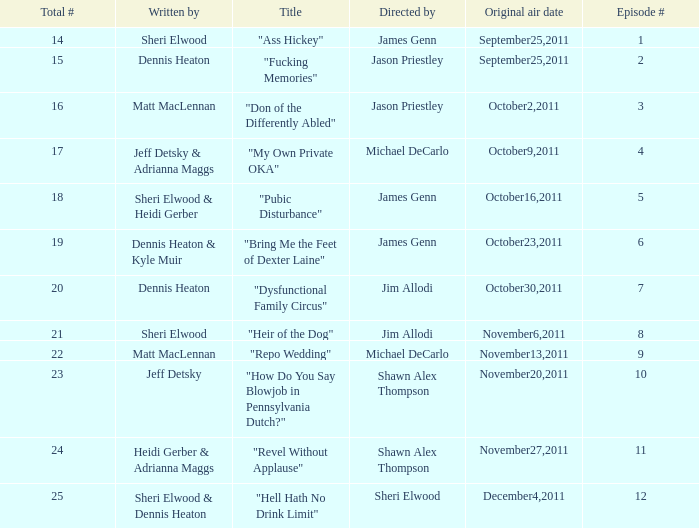How many different episode numbers are there for the episodes directed by Sheri Elwood? 1.0. 